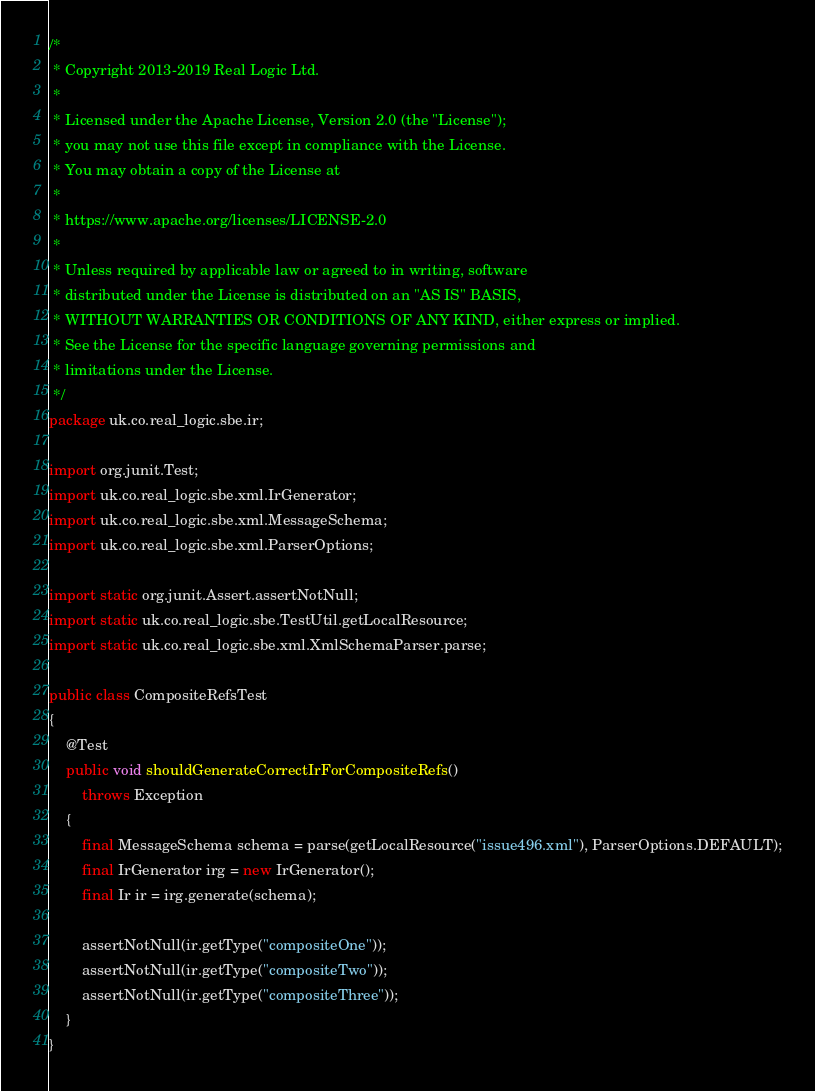<code> <loc_0><loc_0><loc_500><loc_500><_Java_>/*
 * Copyright 2013-2019 Real Logic Ltd.
 *
 * Licensed under the Apache License, Version 2.0 (the "License");
 * you may not use this file except in compliance with the License.
 * You may obtain a copy of the License at
 *
 * https://www.apache.org/licenses/LICENSE-2.0
 *
 * Unless required by applicable law or agreed to in writing, software
 * distributed under the License is distributed on an "AS IS" BASIS,
 * WITHOUT WARRANTIES OR CONDITIONS OF ANY KIND, either express or implied.
 * See the License for the specific language governing permissions and
 * limitations under the License.
 */
package uk.co.real_logic.sbe.ir;

import org.junit.Test;
import uk.co.real_logic.sbe.xml.IrGenerator;
import uk.co.real_logic.sbe.xml.MessageSchema;
import uk.co.real_logic.sbe.xml.ParserOptions;

import static org.junit.Assert.assertNotNull;
import static uk.co.real_logic.sbe.TestUtil.getLocalResource;
import static uk.co.real_logic.sbe.xml.XmlSchemaParser.parse;

public class CompositeRefsTest
{
    @Test
    public void shouldGenerateCorrectIrForCompositeRefs()
        throws Exception
    {
        final MessageSchema schema = parse(getLocalResource("issue496.xml"), ParserOptions.DEFAULT);
        final IrGenerator irg = new IrGenerator();
        final Ir ir = irg.generate(schema);

        assertNotNull(ir.getType("compositeOne"));
        assertNotNull(ir.getType("compositeTwo"));
        assertNotNull(ir.getType("compositeThree"));
    }
}
</code> 